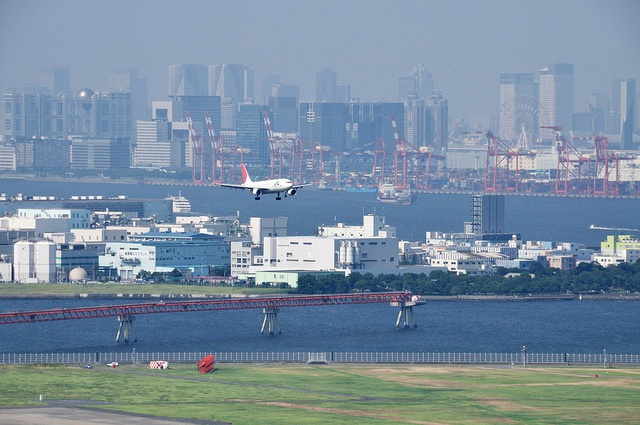Describe the objects in this image and their specific colors. I can see airplane in gray, white, and navy tones, boat in gray, darkgray, and lightgray tones, boat in gray, lightgray, and darkgray tones, and boat in gray, white, and darkgray tones in this image. 